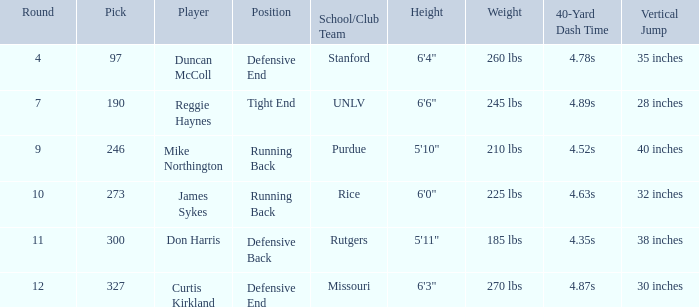What is the highest round number for the player who came from team Missouri? 12.0. 